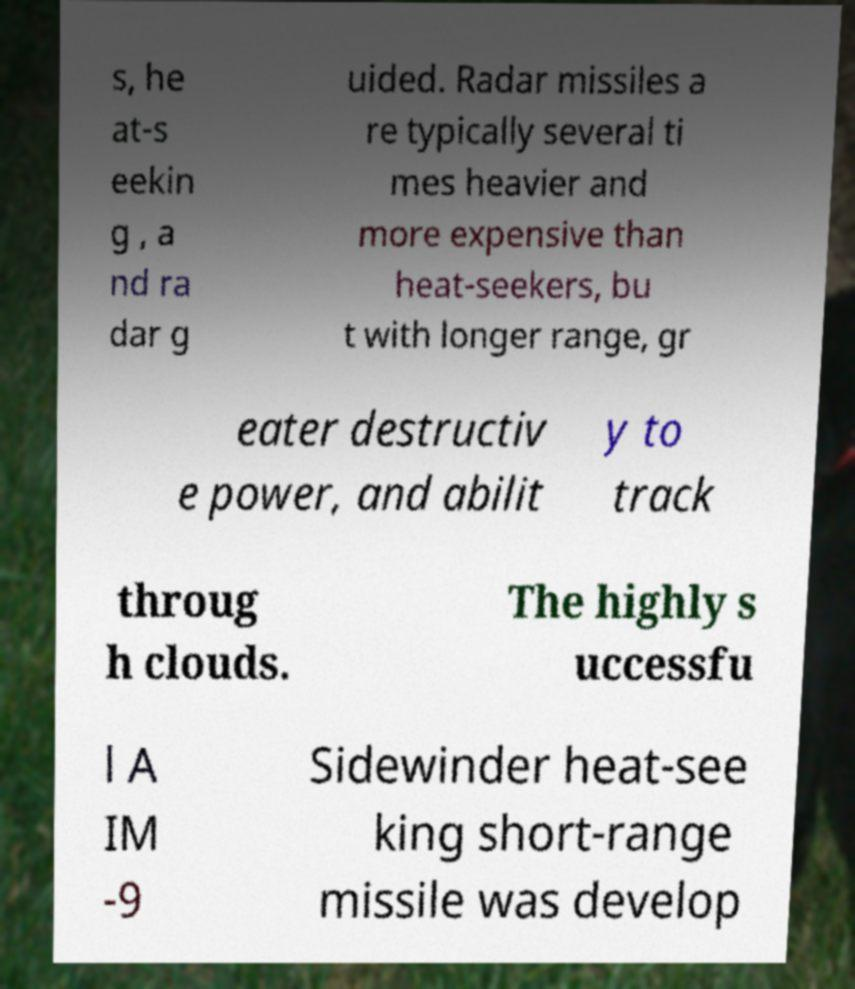Please identify and transcribe the text found in this image. s, he at-s eekin g , a nd ra dar g uided. Radar missiles a re typically several ti mes heavier and more expensive than heat-seekers, bu t with longer range, gr eater destructiv e power, and abilit y to track throug h clouds. The highly s uccessfu l A IM -9 Sidewinder heat-see king short-range missile was develop 